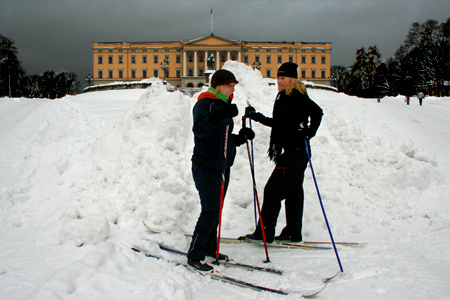Imagine a story where these two individuals are on a secret mission. What is their mission? In a world where ancient secrets are hidden within monumental buildings, these two individuals are secret agents on a mission to retrieve a mysterious artifact buried beneath the historic site they are skiing in front of. They use their skiing trip as a cover to blend in with the environment and avoid suspicion. Their goal is to enter the building at night, bypass security systems, and unlock a hidden chamber that holds the artifact, which is said to possess the power to change the course of history. 